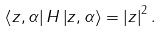<formula> <loc_0><loc_0><loc_500><loc_500>\left \langle z , \alpha \right | H \left | z , \alpha \right \rangle = \left | z \right | ^ { 2 } .</formula> 